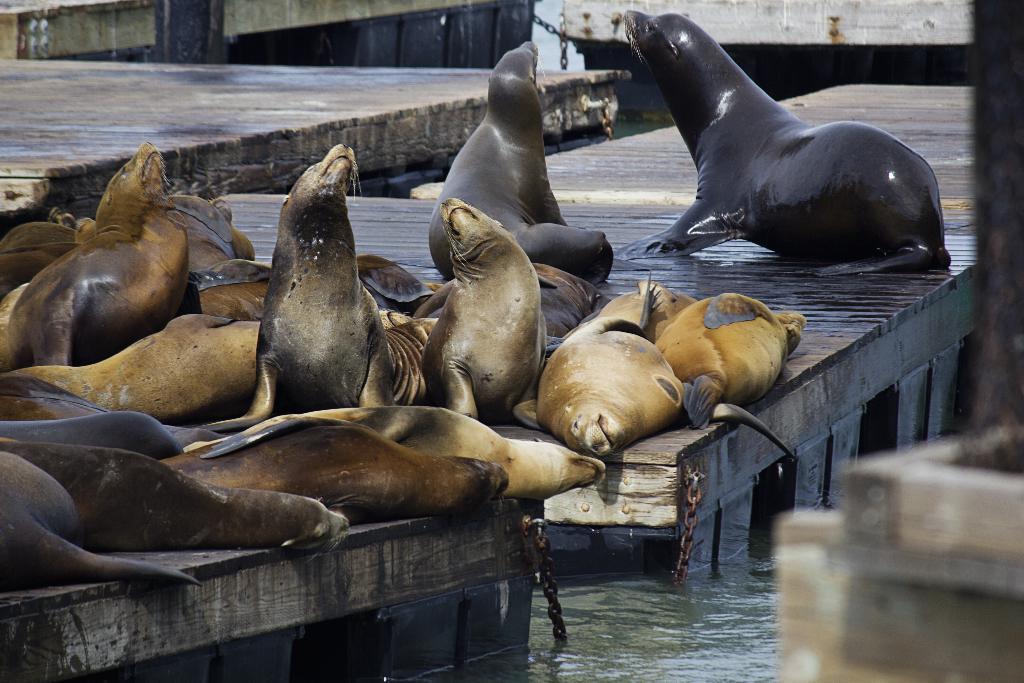In one or two sentences, can you explain what this image depicts? In this image there are so many sea lions sitting on the bridge, which is on water. 